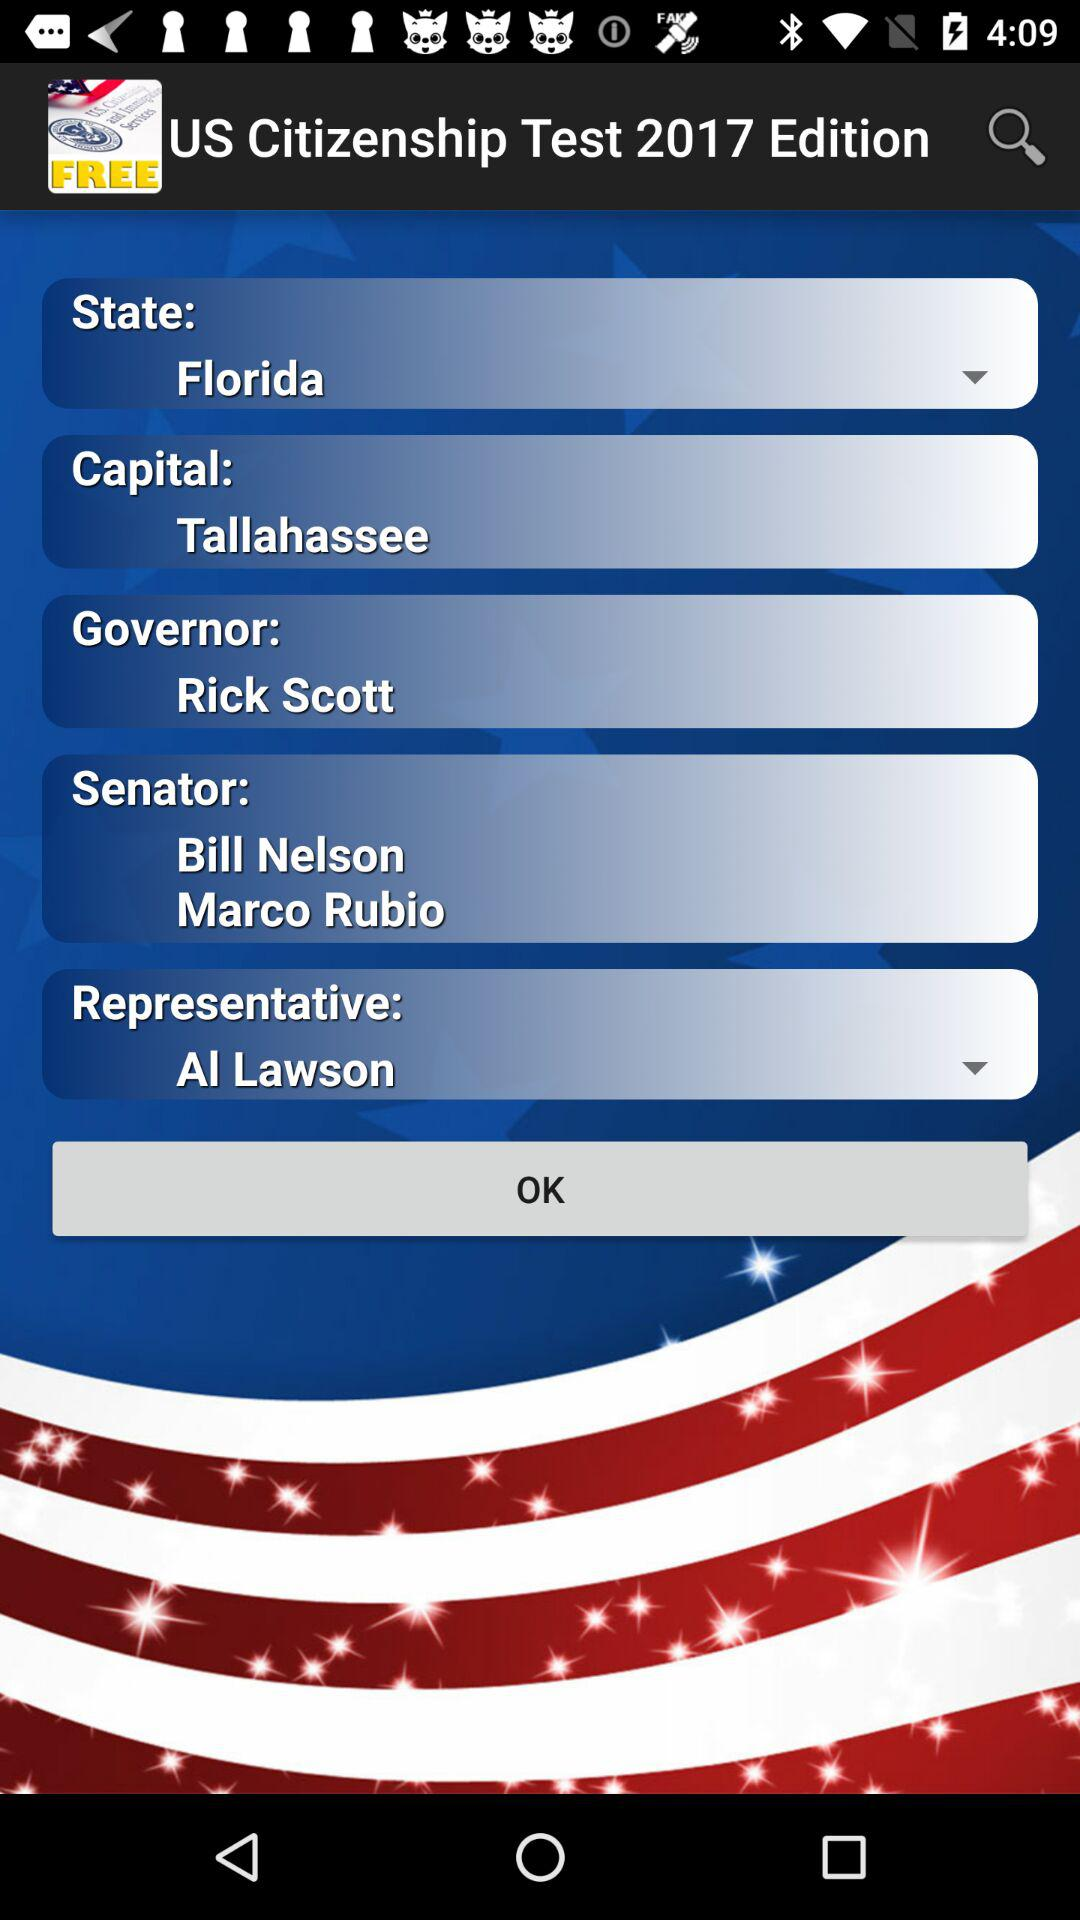Who is the selected representative? The selected representative is Al Lawson. 